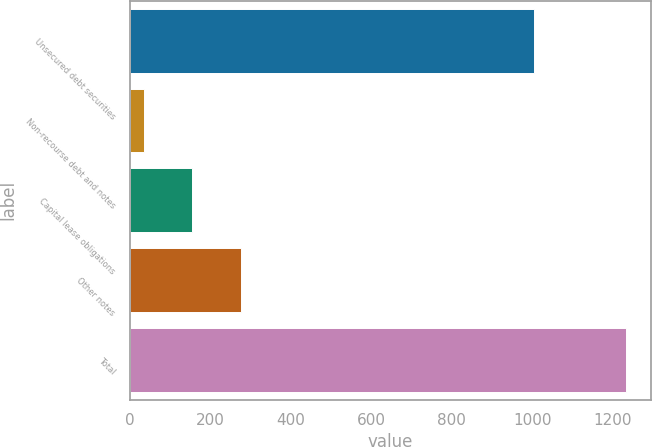Convert chart to OTSL. <chart><loc_0><loc_0><loc_500><loc_500><bar_chart><fcel>Unsecured debt securities<fcel>Non-recourse debt and notes<fcel>Capital lease obligations<fcel>Other notes<fcel>Total<nl><fcel>1004<fcel>36<fcel>155.8<fcel>275.6<fcel>1234<nl></chart> 